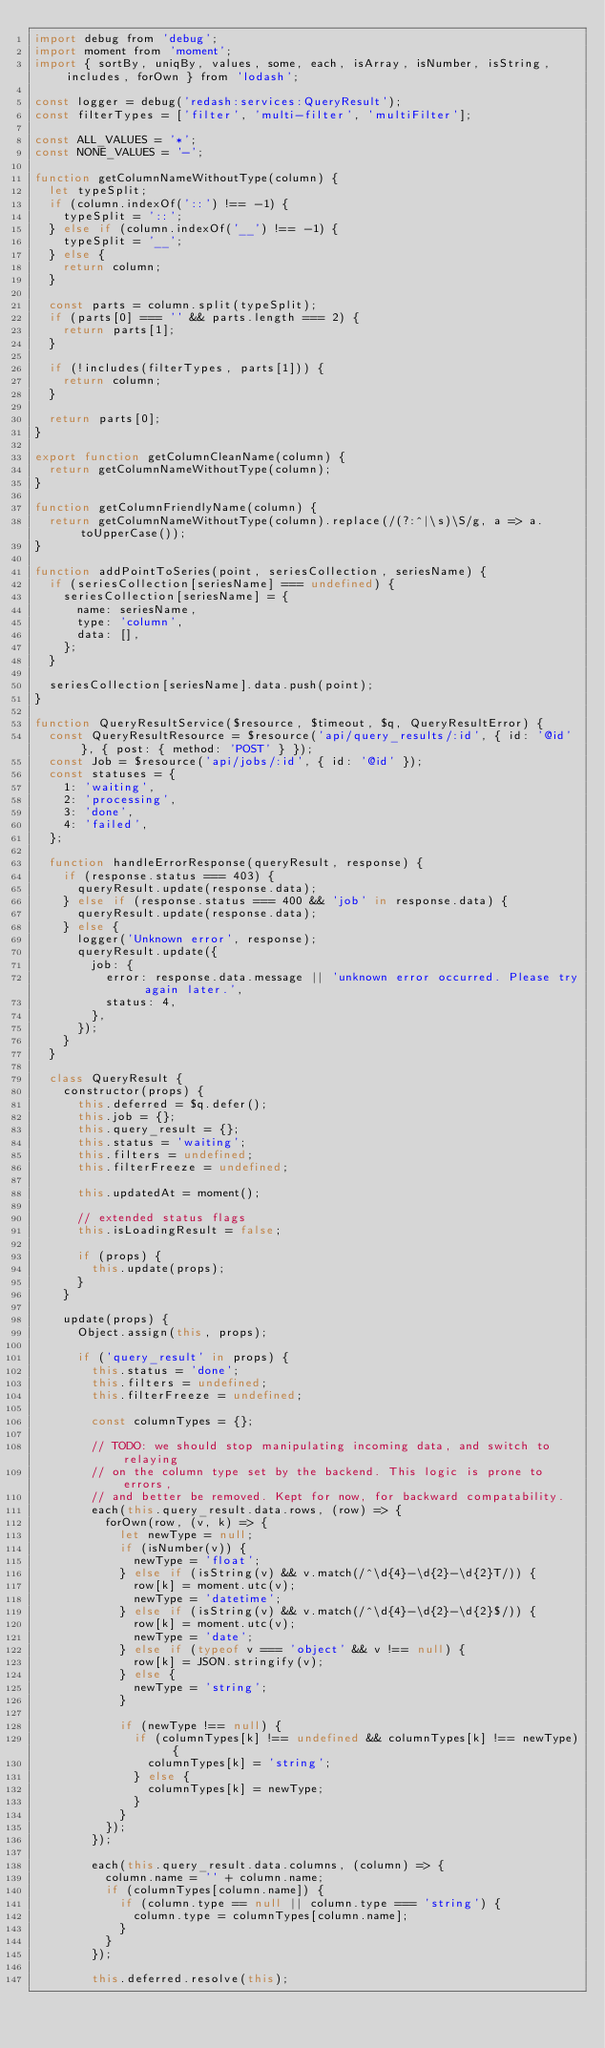Convert code to text. <code><loc_0><loc_0><loc_500><loc_500><_JavaScript_>import debug from 'debug';
import moment from 'moment';
import { sortBy, uniqBy, values, some, each, isArray, isNumber, isString, includes, forOwn } from 'lodash';

const logger = debug('redash:services:QueryResult');
const filterTypes = ['filter', 'multi-filter', 'multiFilter'];

const ALL_VALUES = '*';
const NONE_VALUES = '-';

function getColumnNameWithoutType(column) {
  let typeSplit;
  if (column.indexOf('::') !== -1) {
    typeSplit = '::';
  } else if (column.indexOf('__') !== -1) {
    typeSplit = '__';
  } else {
    return column;
  }

  const parts = column.split(typeSplit);
  if (parts[0] === '' && parts.length === 2) {
    return parts[1];
  }

  if (!includes(filterTypes, parts[1])) {
    return column;
  }

  return parts[0];
}

export function getColumnCleanName(column) {
  return getColumnNameWithoutType(column);
}

function getColumnFriendlyName(column) {
  return getColumnNameWithoutType(column).replace(/(?:^|\s)\S/g, a => a.toUpperCase());
}

function addPointToSeries(point, seriesCollection, seriesName) {
  if (seriesCollection[seriesName] === undefined) {
    seriesCollection[seriesName] = {
      name: seriesName,
      type: 'column',
      data: [],
    };
  }

  seriesCollection[seriesName].data.push(point);
}

function QueryResultService($resource, $timeout, $q, QueryResultError) {
  const QueryResultResource = $resource('api/query_results/:id', { id: '@id' }, { post: { method: 'POST' } });
  const Job = $resource('api/jobs/:id', { id: '@id' });
  const statuses = {
    1: 'waiting',
    2: 'processing',
    3: 'done',
    4: 'failed',
  };

  function handleErrorResponse(queryResult, response) {
    if (response.status === 403) {
      queryResult.update(response.data);
    } else if (response.status === 400 && 'job' in response.data) {
      queryResult.update(response.data);
    } else {
      logger('Unknown error', response);
      queryResult.update({
        job: {
          error: response.data.message || 'unknown error occurred. Please try again later.',
          status: 4,
        },
      });
    }
  }

  class QueryResult {
    constructor(props) {
      this.deferred = $q.defer();
      this.job = {};
      this.query_result = {};
      this.status = 'waiting';
      this.filters = undefined;
      this.filterFreeze = undefined;

      this.updatedAt = moment();

      // extended status flags
      this.isLoadingResult = false;

      if (props) {
        this.update(props);
      }
    }

    update(props) {
      Object.assign(this, props);

      if ('query_result' in props) {
        this.status = 'done';
        this.filters = undefined;
        this.filterFreeze = undefined;

        const columnTypes = {};

        // TODO: we should stop manipulating incoming data, and switch to relaying
        // on the column type set by the backend. This logic is prone to errors,
        // and better be removed. Kept for now, for backward compatability.
        each(this.query_result.data.rows, (row) => {
          forOwn(row, (v, k) => {
            let newType = null;
            if (isNumber(v)) {
              newType = 'float';
            } else if (isString(v) && v.match(/^\d{4}-\d{2}-\d{2}T/)) {
              row[k] = moment.utc(v);
              newType = 'datetime';
            } else if (isString(v) && v.match(/^\d{4}-\d{2}-\d{2}$/)) {
              row[k] = moment.utc(v);
              newType = 'date';
            } else if (typeof v === 'object' && v !== null) {
              row[k] = JSON.stringify(v);
            } else {
              newType = 'string';
            }

            if (newType !== null) {
              if (columnTypes[k] !== undefined && columnTypes[k] !== newType) {
                columnTypes[k] = 'string';
              } else {
                columnTypes[k] = newType;
              }
            }
          });
        });

        each(this.query_result.data.columns, (column) => {
          column.name = '' + column.name;
          if (columnTypes[column.name]) {
            if (column.type == null || column.type === 'string') {
              column.type = columnTypes[column.name];
            }
          }
        });

        this.deferred.resolve(this);</code> 